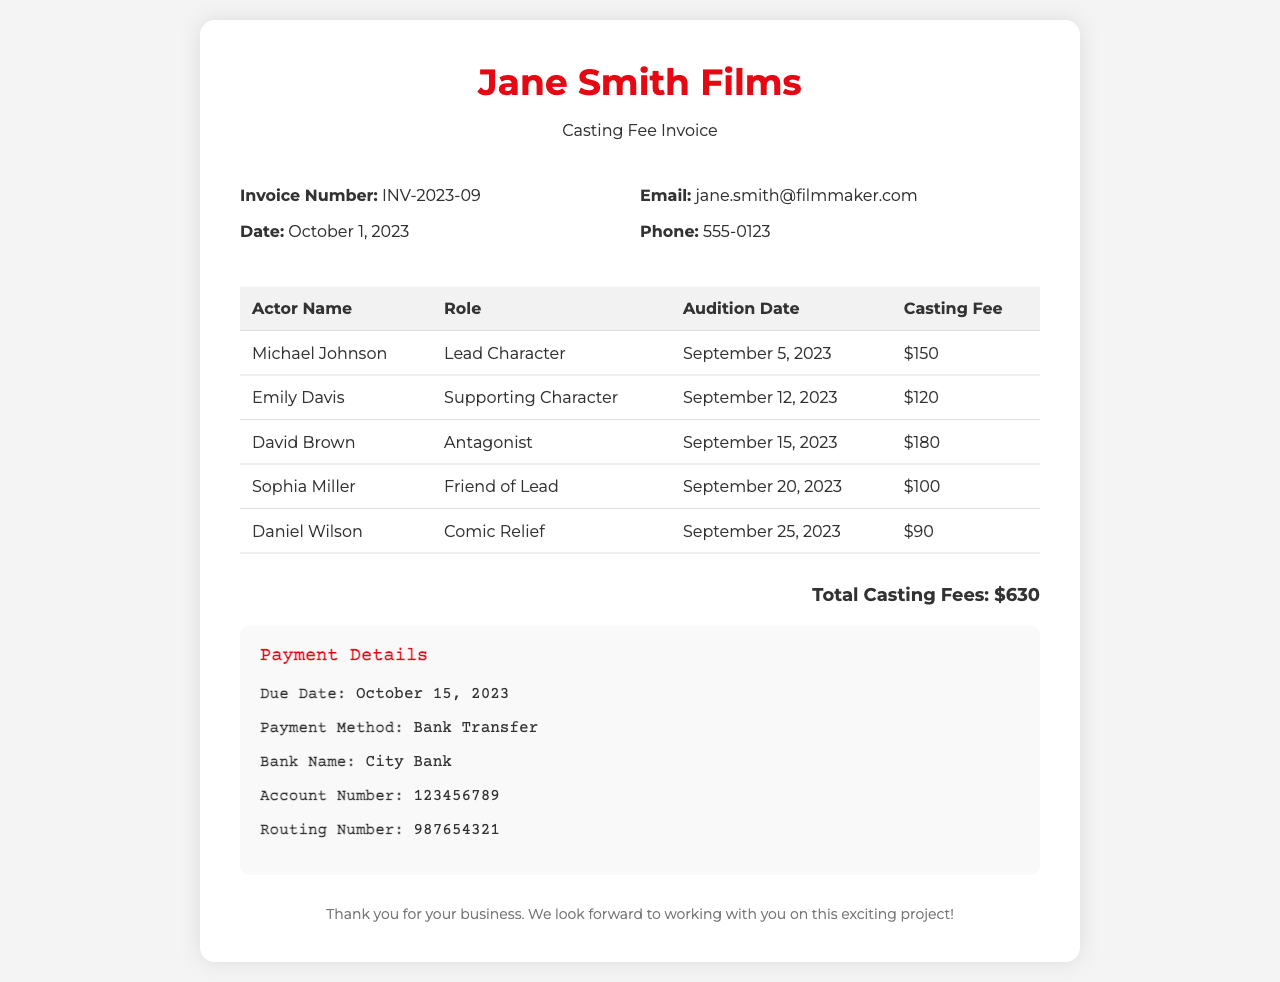What is the invoice number? The invoice number is clearly indicated on the document, which is INV-2023-09.
Answer: INV-2023-09 Who is the lead character's actor? The document lists Michael Johnson as the actor for the lead character role.
Answer: Michael Johnson What is the total casting fee? The total casting fee is specified at the bottom of the invoice as the sum of individual fees, which is $630.
Answer: $630 When was Emily Davis's audition date? The document provides Emily Davis's audition date as September 12, 2023.
Answer: September 12, 2023 What role did David Brown audition for? David Brown is specified in the document as auditioning for the antagonist role.
Answer: Antagonist What payment method is listed in the invoice? The method of payment mentioned in the payment details section is bank transfer.
Answer: Bank Transfer What is the due date for payment? The invoice states that the payment is due on October 15, 2023.
Answer: October 15, 2023 How many actors were auditioned in September 2023? The document lists five actors who auditioned, providing individual details for each.
Answer: Five What is the casting fee for the comic relief role? The casting fee for the comic relief role played by Daniel Wilson is clearly stated as $90.
Answer: $90 